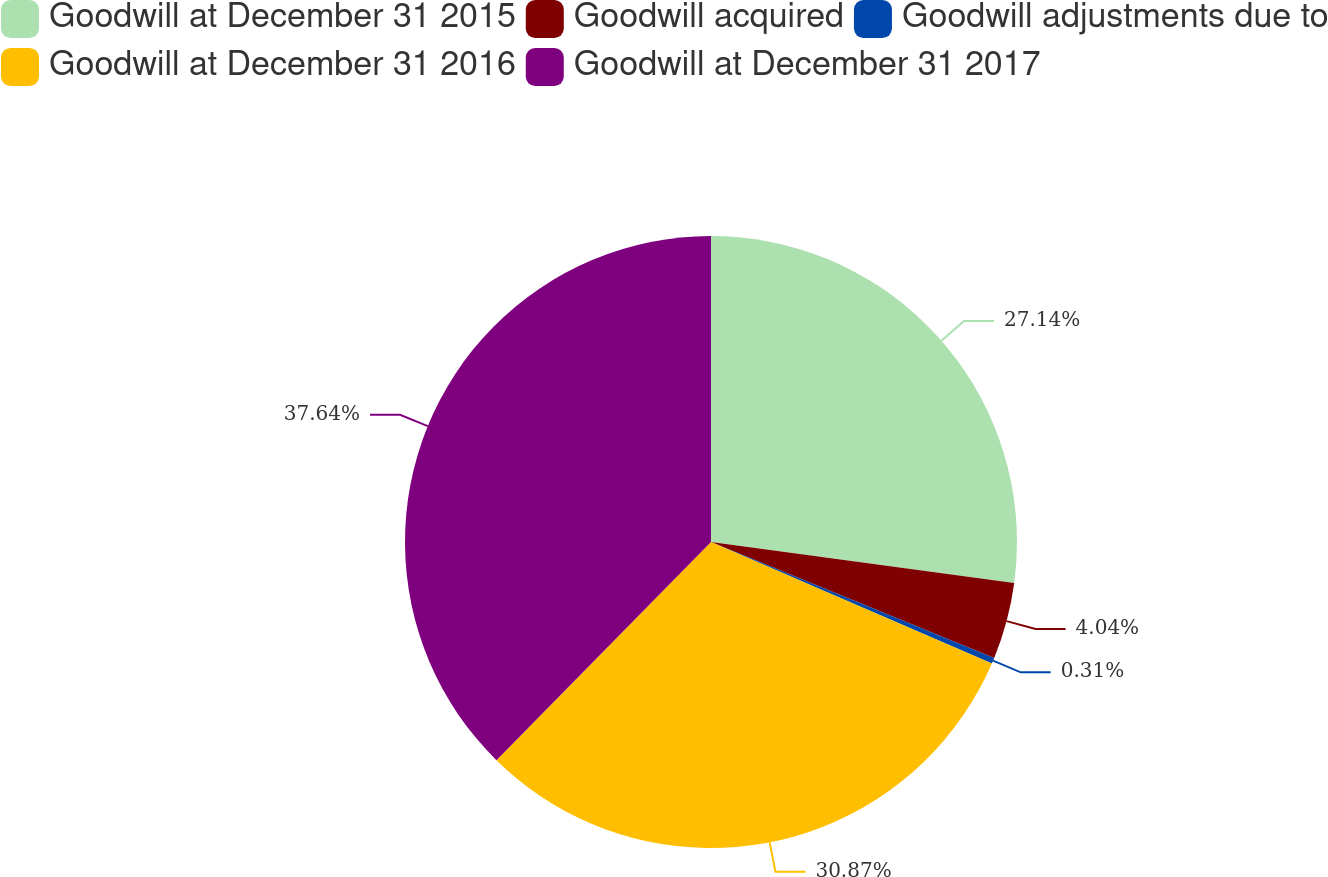<chart> <loc_0><loc_0><loc_500><loc_500><pie_chart><fcel>Goodwill at December 31 2015<fcel>Goodwill acquired<fcel>Goodwill adjustments due to<fcel>Goodwill at December 31 2016<fcel>Goodwill at December 31 2017<nl><fcel>27.14%<fcel>4.04%<fcel>0.31%<fcel>30.87%<fcel>37.63%<nl></chart> 